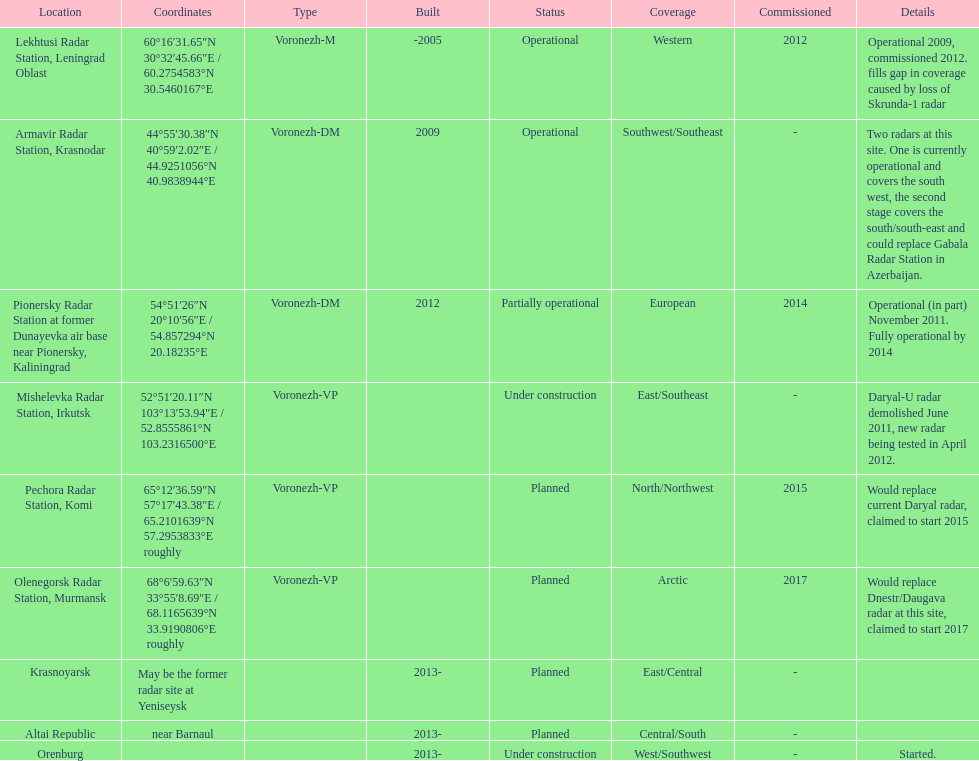Which site has the most radars? Armavir Radar Station, Krasnodar. 